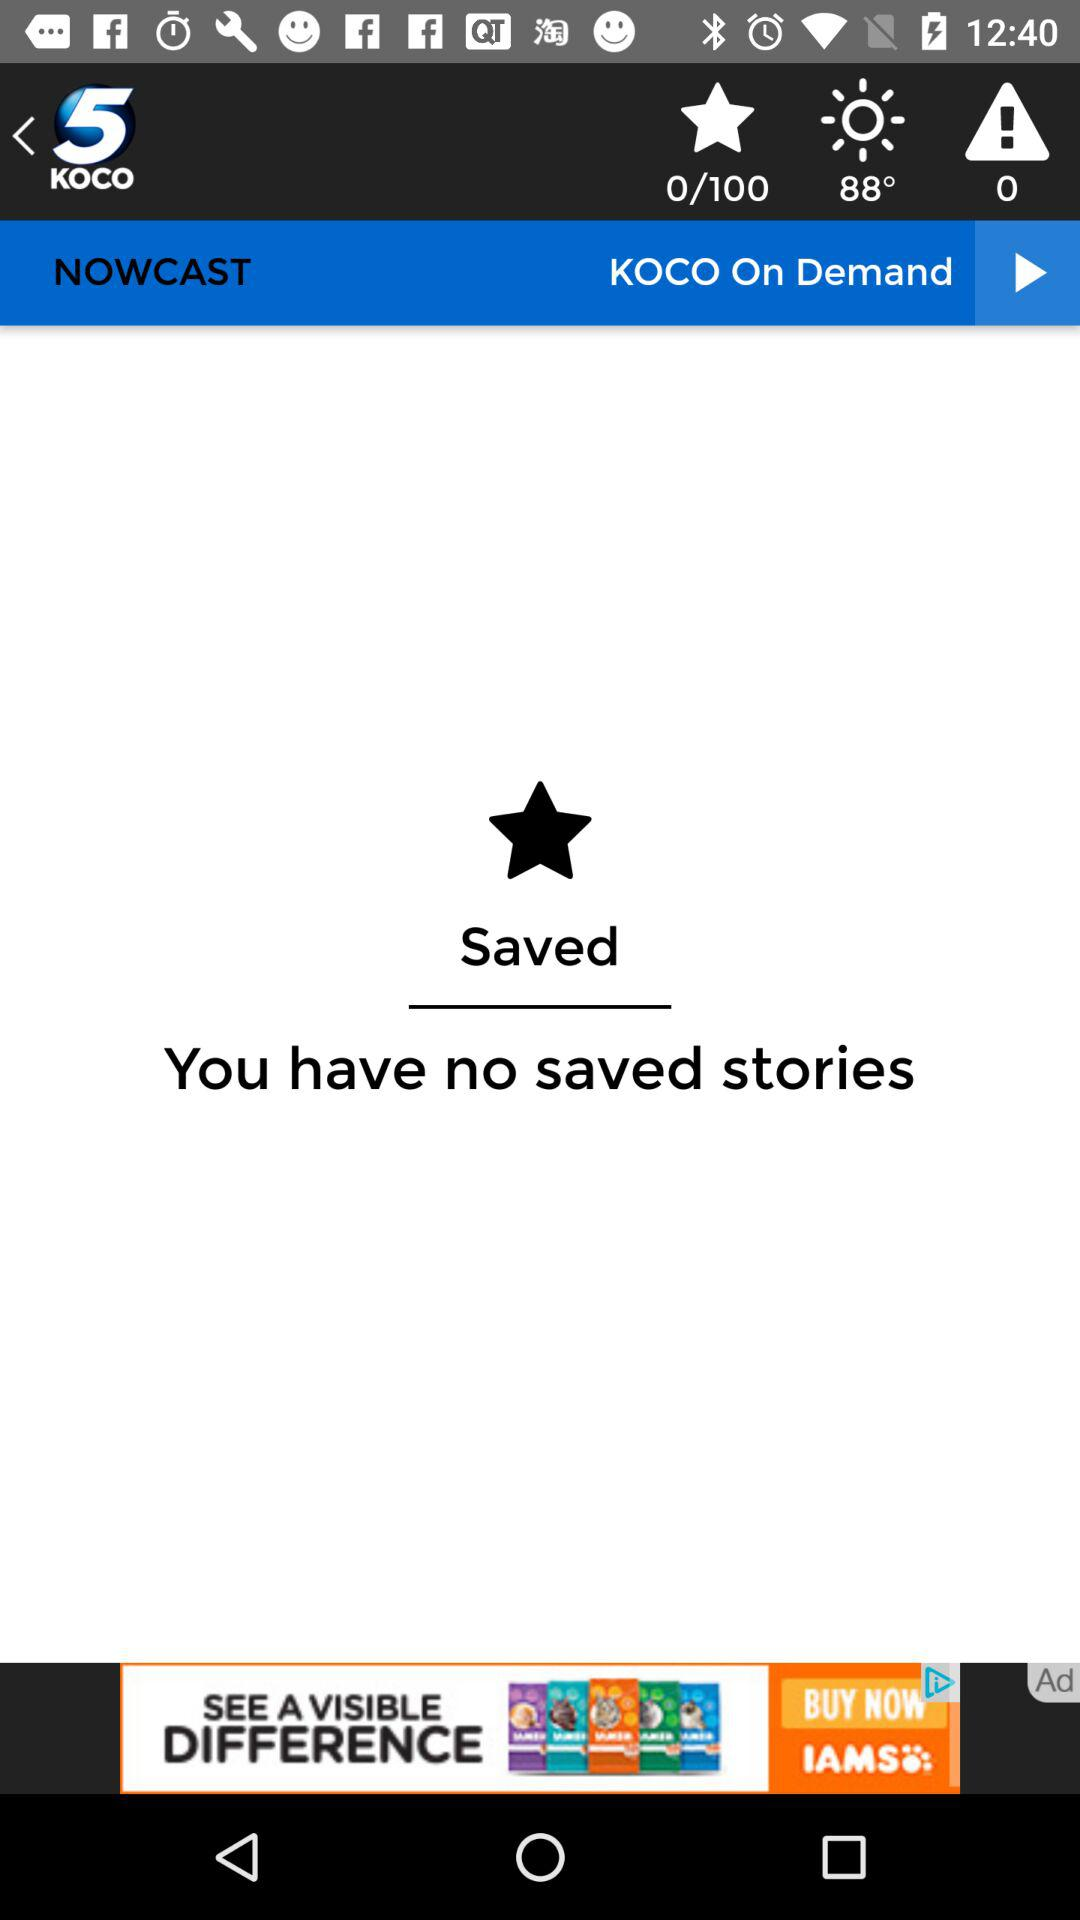What is the current star page? The current star page is 0. 